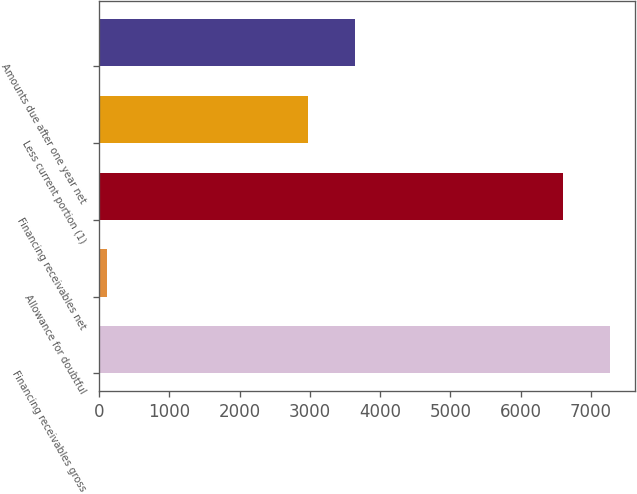<chart> <loc_0><loc_0><loc_500><loc_500><bar_chart><fcel>Financing receivables gross<fcel>Allowance for doubtful<fcel>Financing receivables net<fcel>Less current portion (1)<fcel>Amounts due after one year net<nl><fcel>7267.7<fcel>111<fcel>6607<fcel>2974<fcel>3634.7<nl></chart> 